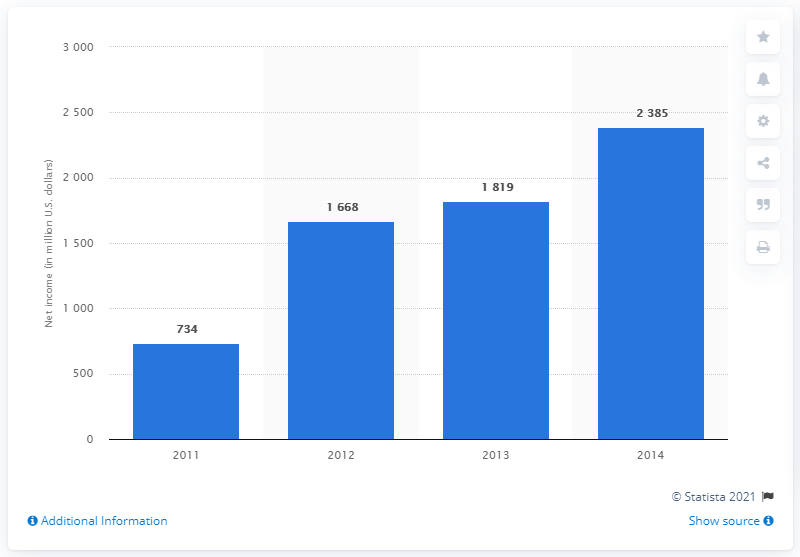Identify some key points in this picture. The sum total value of net income in the years 2012 and 2011 is 2406. The net income of 2014 had the highest value among all the years. 